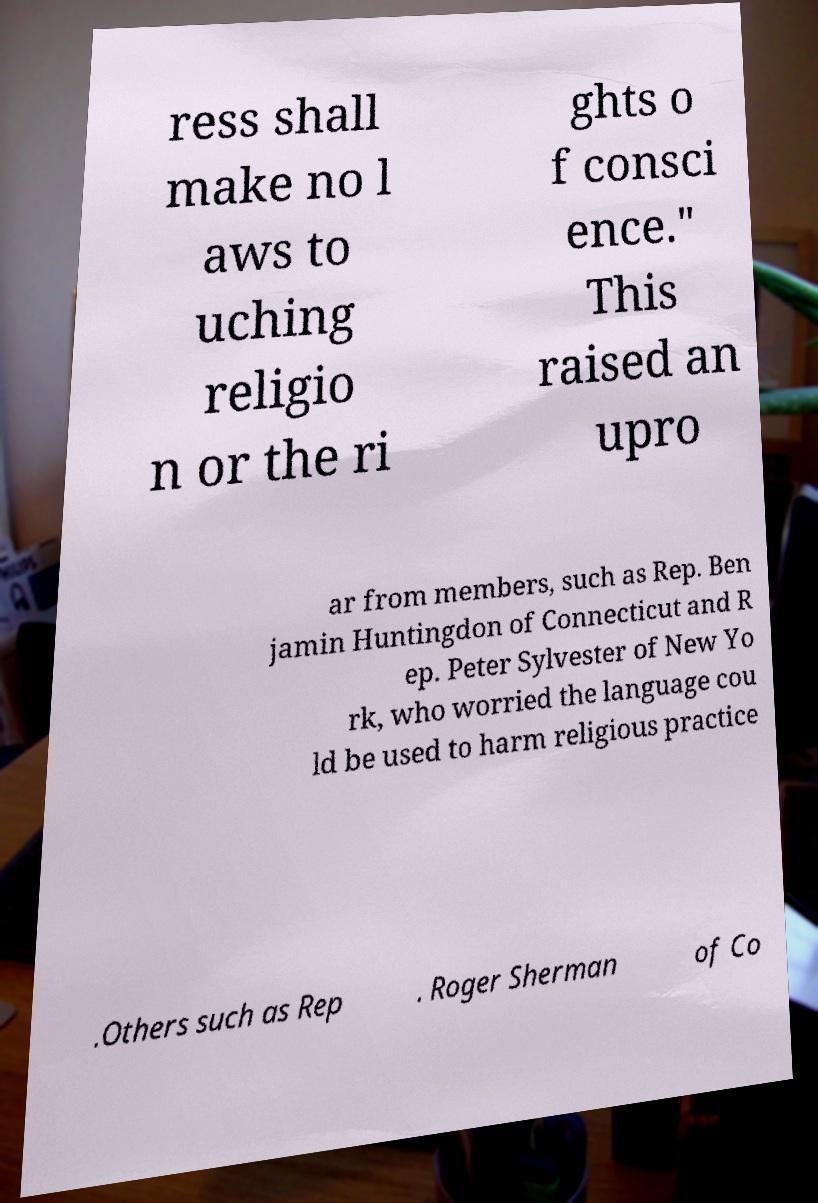Please read and relay the text visible in this image. What does it say? ress shall make no l aws to uching religio n or the ri ghts o f consci ence." This raised an upro ar from members, such as Rep. Ben jamin Huntingdon of Connecticut and R ep. Peter Sylvester of New Yo rk, who worried the language cou ld be used to harm religious practice .Others such as Rep . Roger Sherman of Co 